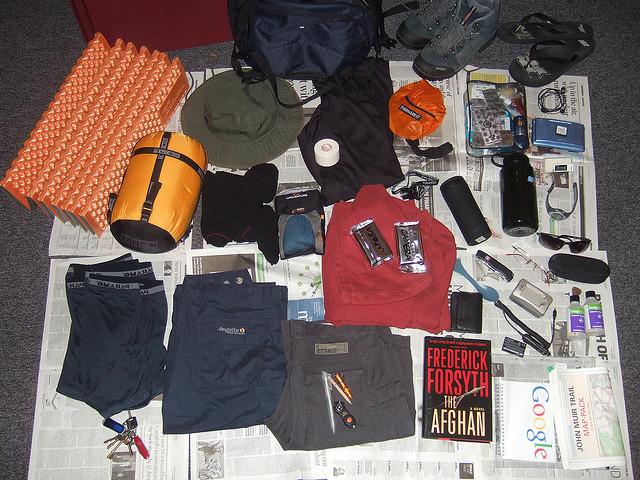What kind of shoes are on the right?
Answer briefly. Flip flops. What is the title of the book in the picture?
Answer briefly. Afghan. What is this person packing for?
Answer briefly. Camping. 